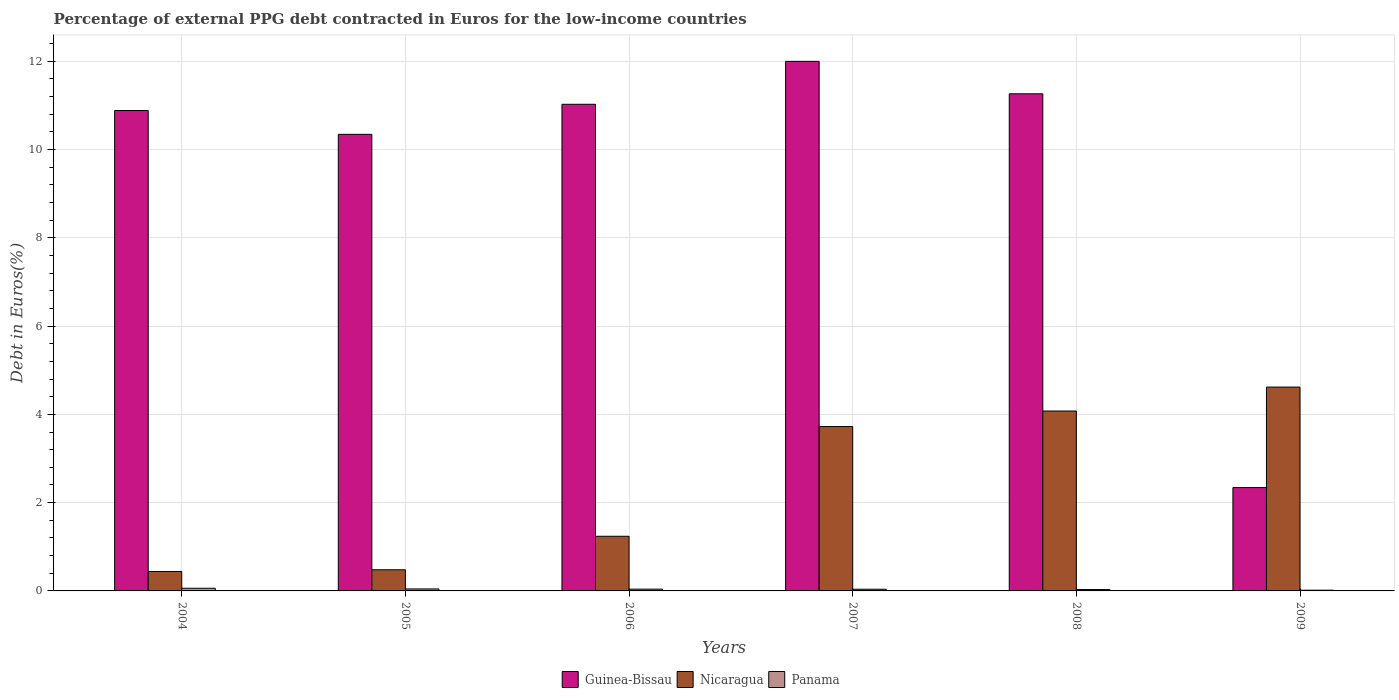How many different coloured bars are there?
Provide a succinct answer. 3. Are the number of bars on each tick of the X-axis equal?
Provide a succinct answer. Yes. In how many cases, is the number of bars for a given year not equal to the number of legend labels?
Offer a very short reply. 0. What is the percentage of external PPG debt contracted in Euros in Panama in 2005?
Ensure brevity in your answer.  0.04. Across all years, what is the maximum percentage of external PPG debt contracted in Euros in Panama?
Your response must be concise. 0.06. Across all years, what is the minimum percentage of external PPG debt contracted in Euros in Guinea-Bissau?
Ensure brevity in your answer.  2.34. In which year was the percentage of external PPG debt contracted in Euros in Panama minimum?
Provide a short and direct response. 2009. What is the total percentage of external PPG debt contracted in Euros in Nicaragua in the graph?
Offer a terse response. 14.58. What is the difference between the percentage of external PPG debt contracted in Euros in Nicaragua in 2007 and that in 2008?
Your response must be concise. -0.35. What is the difference between the percentage of external PPG debt contracted in Euros in Panama in 2007 and the percentage of external PPG debt contracted in Euros in Guinea-Bissau in 2006?
Keep it short and to the point. -10.99. What is the average percentage of external PPG debt contracted in Euros in Panama per year?
Your answer should be compact. 0.04. In the year 2008, what is the difference between the percentage of external PPG debt contracted in Euros in Nicaragua and percentage of external PPG debt contracted in Euros in Guinea-Bissau?
Offer a terse response. -7.19. In how many years, is the percentage of external PPG debt contracted in Euros in Guinea-Bissau greater than 5.6 %?
Your answer should be compact. 5. What is the ratio of the percentage of external PPG debt contracted in Euros in Nicaragua in 2004 to that in 2005?
Provide a succinct answer. 0.92. Is the percentage of external PPG debt contracted in Euros in Nicaragua in 2005 less than that in 2006?
Ensure brevity in your answer.  Yes. Is the difference between the percentage of external PPG debt contracted in Euros in Nicaragua in 2007 and 2008 greater than the difference between the percentage of external PPG debt contracted in Euros in Guinea-Bissau in 2007 and 2008?
Your answer should be very brief. No. What is the difference between the highest and the second highest percentage of external PPG debt contracted in Euros in Nicaragua?
Your answer should be very brief. 0.54. What is the difference between the highest and the lowest percentage of external PPG debt contracted in Euros in Guinea-Bissau?
Your response must be concise. 9.66. In how many years, is the percentage of external PPG debt contracted in Euros in Panama greater than the average percentage of external PPG debt contracted in Euros in Panama taken over all years?
Make the answer very short. 3. What does the 2nd bar from the left in 2007 represents?
Provide a short and direct response. Nicaragua. What does the 2nd bar from the right in 2009 represents?
Your answer should be compact. Nicaragua. Is it the case that in every year, the sum of the percentage of external PPG debt contracted in Euros in Panama and percentage of external PPG debt contracted in Euros in Guinea-Bissau is greater than the percentage of external PPG debt contracted in Euros in Nicaragua?
Your answer should be compact. No. What is the difference between two consecutive major ticks on the Y-axis?
Offer a very short reply. 2. Does the graph contain any zero values?
Keep it short and to the point. No. Where does the legend appear in the graph?
Keep it short and to the point. Bottom center. How many legend labels are there?
Provide a succinct answer. 3. What is the title of the graph?
Your response must be concise. Percentage of external PPG debt contracted in Euros for the low-income countries. What is the label or title of the X-axis?
Make the answer very short. Years. What is the label or title of the Y-axis?
Give a very brief answer. Debt in Euros(%). What is the Debt in Euros(%) of Guinea-Bissau in 2004?
Keep it short and to the point. 10.88. What is the Debt in Euros(%) in Nicaragua in 2004?
Your answer should be compact. 0.44. What is the Debt in Euros(%) of Panama in 2004?
Provide a succinct answer. 0.06. What is the Debt in Euros(%) in Guinea-Bissau in 2005?
Provide a succinct answer. 10.34. What is the Debt in Euros(%) of Nicaragua in 2005?
Ensure brevity in your answer.  0.48. What is the Debt in Euros(%) of Panama in 2005?
Your answer should be compact. 0.04. What is the Debt in Euros(%) of Guinea-Bissau in 2006?
Give a very brief answer. 11.02. What is the Debt in Euros(%) of Nicaragua in 2006?
Offer a very short reply. 1.24. What is the Debt in Euros(%) of Panama in 2006?
Make the answer very short. 0.04. What is the Debt in Euros(%) in Guinea-Bissau in 2007?
Offer a very short reply. 12. What is the Debt in Euros(%) in Nicaragua in 2007?
Make the answer very short. 3.72. What is the Debt in Euros(%) in Panama in 2007?
Make the answer very short. 0.04. What is the Debt in Euros(%) of Guinea-Bissau in 2008?
Your response must be concise. 11.26. What is the Debt in Euros(%) in Nicaragua in 2008?
Keep it short and to the point. 4.08. What is the Debt in Euros(%) of Panama in 2008?
Provide a succinct answer. 0.03. What is the Debt in Euros(%) in Guinea-Bissau in 2009?
Offer a terse response. 2.34. What is the Debt in Euros(%) of Nicaragua in 2009?
Give a very brief answer. 4.62. What is the Debt in Euros(%) of Panama in 2009?
Provide a succinct answer. 0.02. Across all years, what is the maximum Debt in Euros(%) in Guinea-Bissau?
Provide a succinct answer. 12. Across all years, what is the maximum Debt in Euros(%) in Nicaragua?
Provide a succinct answer. 4.62. Across all years, what is the maximum Debt in Euros(%) of Panama?
Your response must be concise. 0.06. Across all years, what is the minimum Debt in Euros(%) in Guinea-Bissau?
Keep it short and to the point. 2.34. Across all years, what is the minimum Debt in Euros(%) in Nicaragua?
Ensure brevity in your answer.  0.44. Across all years, what is the minimum Debt in Euros(%) of Panama?
Provide a succinct answer. 0.02. What is the total Debt in Euros(%) in Guinea-Bissau in the graph?
Provide a short and direct response. 57.85. What is the total Debt in Euros(%) in Nicaragua in the graph?
Offer a terse response. 14.58. What is the total Debt in Euros(%) in Panama in the graph?
Provide a short and direct response. 0.23. What is the difference between the Debt in Euros(%) in Guinea-Bissau in 2004 and that in 2005?
Ensure brevity in your answer.  0.54. What is the difference between the Debt in Euros(%) of Nicaragua in 2004 and that in 2005?
Your response must be concise. -0.04. What is the difference between the Debt in Euros(%) of Panama in 2004 and that in 2005?
Ensure brevity in your answer.  0.02. What is the difference between the Debt in Euros(%) of Guinea-Bissau in 2004 and that in 2006?
Offer a very short reply. -0.14. What is the difference between the Debt in Euros(%) in Nicaragua in 2004 and that in 2006?
Your answer should be compact. -0.8. What is the difference between the Debt in Euros(%) of Panama in 2004 and that in 2006?
Your answer should be compact. 0.02. What is the difference between the Debt in Euros(%) in Guinea-Bissau in 2004 and that in 2007?
Your response must be concise. -1.11. What is the difference between the Debt in Euros(%) of Nicaragua in 2004 and that in 2007?
Offer a terse response. -3.28. What is the difference between the Debt in Euros(%) of Panama in 2004 and that in 2007?
Provide a short and direct response. 0.02. What is the difference between the Debt in Euros(%) in Guinea-Bissau in 2004 and that in 2008?
Offer a very short reply. -0.38. What is the difference between the Debt in Euros(%) in Nicaragua in 2004 and that in 2008?
Provide a succinct answer. -3.64. What is the difference between the Debt in Euros(%) in Panama in 2004 and that in 2008?
Ensure brevity in your answer.  0.03. What is the difference between the Debt in Euros(%) of Guinea-Bissau in 2004 and that in 2009?
Keep it short and to the point. 8.54. What is the difference between the Debt in Euros(%) in Nicaragua in 2004 and that in 2009?
Your response must be concise. -4.18. What is the difference between the Debt in Euros(%) in Panama in 2004 and that in 2009?
Keep it short and to the point. 0.04. What is the difference between the Debt in Euros(%) in Guinea-Bissau in 2005 and that in 2006?
Ensure brevity in your answer.  -0.68. What is the difference between the Debt in Euros(%) in Nicaragua in 2005 and that in 2006?
Your answer should be compact. -0.76. What is the difference between the Debt in Euros(%) in Panama in 2005 and that in 2006?
Ensure brevity in your answer.  0. What is the difference between the Debt in Euros(%) of Guinea-Bissau in 2005 and that in 2007?
Provide a succinct answer. -1.65. What is the difference between the Debt in Euros(%) in Nicaragua in 2005 and that in 2007?
Your answer should be compact. -3.24. What is the difference between the Debt in Euros(%) of Panama in 2005 and that in 2007?
Give a very brief answer. 0.01. What is the difference between the Debt in Euros(%) in Guinea-Bissau in 2005 and that in 2008?
Provide a short and direct response. -0.92. What is the difference between the Debt in Euros(%) of Nicaragua in 2005 and that in 2008?
Make the answer very short. -3.6. What is the difference between the Debt in Euros(%) of Panama in 2005 and that in 2008?
Keep it short and to the point. 0.01. What is the difference between the Debt in Euros(%) in Guinea-Bissau in 2005 and that in 2009?
Ensure brevity in your answer.  8. What is the difference between the Debt in Euros(%) of Nicaragua in 2005 and that in 2009?
Offer a terse response. -4.14. What is the difference between the Debt in Euros(%) of Panama in 2005 and that in 2009?
Keep it short and to the point. 0.03. What is the difference between the Debt in Euros(%) of Guinea-Bissau in 2006 and that in 2007?
Your answer should be very brief. -0.97. What is the difference between the Debt in Euros(%) of Nicaragua in 2006 and that in 2007?
Offer a very short reply. -2.49. What is the difference between the Debt in Euros(%) in Panama in 2006 and that in 2007?
Provide a succinct answer. 0. What is the difference between the Debt in Euros(%) of Guinea-Bissau in 2006 and that in 2008?
Ensure brevity in your answer.  -0.24. What is the difference between the Debt in Euros(%) of Nicaragua in 2006 and that in 2008?
Provide a succinct answer. -2.84. What is the difference between the Debt in Euros(%) of Panama in 2006 and that in 2008?
Offer a very short reply. 0.01. What is the difference between the Debt in Euros(%) in Guinea-Bissau in 2006 and that in 2009?
Keep it short and to the point. 8.68. What is the difference between the Debt in Euros(%) of Nicaragua in 2006 and that in 2009?
Offer a terse response. -3.38. What is the difference between the Debt in Euros(%) of Panama in 2006 and that in 2009?
Ensure brevity in your answer.  0.02. What is the difference between the Debt in Euros(%) of Guinea-Bissau in 2007 and that in 2008?
Give a very brief answer. 0.73. What is the difference between the Debt in Euros(%) in Nicaragua in 2007 and that in 2008?
Offer a very short reply. -0.35. What is the difference between the Debt in Euros(%) of Panama in 2007 and that in 2008?
Ensure brevity in your answer.  0.01. What is the difference between the Debt in Euros(%) of Guinea-Bissau in 2007 and that in 2009?
Ensure brevity in your answer.  9.66. What is the difference between the Debt in Euros(%) in Nicaragua in 2007 and that in 2009?
Provide a succinct answer. -0.89. What is the difference between the Debt in Euros(%) in Panama in 2007 and that in 2009?
Your answer should be compact. 0.02. What is the difference between the Debt in Euros(%) in Guinea-Bissau in 2008 and that in 2009?
Ensure brevity in your answer.  8.92. What is the difference between the Debt in Euros(%) in Nicaragua in 2008 and that in 2009?
Make the answer very short. -0.54. What is the difference between the Debt in Euros(%) in Panama in 2008 and that in 2009?
Offer a terse response. 0.01. What is the difference between the Debt in Euros(%) of Guinea-Bissau in 2004 and the Debt in Euros(%) of Nicaragua in 2005?
Ensure brevity in your answer.  10.4. What is the difference between the Debt in Euros(%) in Guinea-Bissau in 2004 and the Debt in Euros(%) in Panama in 2005?
Make the answer very short. 10.84. What is the difference between the Debt in Euros(%) of Nicaragua in 2004 and the Debt in Euros(%) of Panama in 2005?
Your response must be concise. 0.4. What is the difference between the Debt in Euros(%) in Guinea-Bissau in 2004 and the Debt in Euros(%) in Nicaragua in 2006?
Give a very brief answer. 9.65. What is the difference between the Debt in Euros(%) in Guinea-Bissau in 2004 and the Debt in Euros(%) in Panama in 2006?
Provide a short and direct response. 10.84. What is the difference between the Debt in Euros(%) of Nicaragua in 2004 and the Debt in Euros(%) of Panama in 2006?
Provide a short and direct response. 0.4. What is the difference between the Debt in Euros(%) in Guinea-Bissau in 2004 and the Debt in Euros(%) in Nicaragua in 2007?
Your answer should be very brief. 7.16. What is the difference between the Debt in Euros(%) in Guinea-Bissau in 2004 and the Debt in Euros(%) in Panama in 2007?
Offer a terse response. 10.85. What is the difference between the Debt in Euros(%) in Nicaragua in 2004 and the Debt in Euros(%) in Panama in 2007?
Keep it short and to the point. 0.4. What is the difference between the Debt in Euros(%) in Guinea-Bissau in 2004 and the Debt in Euros(%) in Nicaragua in 2008?
Give a very brief answer. 6.81. What is the difference between the Debt in Euros(%) of Guinea-Bissau in 2004 and the Debt in Euros(%) of Panama in 2008?
Your response must be concise. 10.85. What is the difference between the Debt in Euros(%) of Nicaragua in 2004 and the Debt in Euros(%) of Panama in 2008?
Provide a short and direct response. 0.41. What is the difference between the Debt in Euros(%) in Guinea-Bissau in 2004 and the Debt in Euros(%) in Nicaragua in 2009?
Offer a terse response. 6.27. What is the difference between the Debt in Euros(%) in Guinea-Bissau in 2004 and the Debt in Euros(%) in Panama in 2009?
Your response must be concise. 10.87. What is the difference between the Debt in Euros(%) in Nicaragua in 2004 and the Debt in Euros(%) in Panama in 2009?
Provide a short and direct response. 0.42. What is the difference between the Debt in Euros(%) in Guinea-Bissau in 2005 and the Debt in Euros(%) in Nicaragua in 2006?
Offer a terse response. 9.11. What is the difference between the Debt in Euros(%) in Guinea-Bissau in 2005 and the Debt in Euros(%) in Panama in 2006?
Your response must be concise. 10.3. What is the difference between the Debt in Euros(%) of Nicaragua in 2005 and the Debt in Euros(%) of Panama in 2006?
Offer a very short reply. 0.44. What is the difference between the Debt in Euros(%) in Guinea-Bissau in 2005 and the Debt in Euros(%) in Nicaragua in 2007?
Offer a very short reply. 6.62. What is the difference between the Debt in Euros(%) in Guinea-Bissau in 2005 and the Debt in Euros(%) in Panama in 2007?
Offer a very short reply. 10.31. What is the difference between the Debt in Euros(%) in Nicaragua in 2005 and the Debt in Euros(%) in Panama in 2007?
Ensure brevity in your answer.  0.44. What is the difference between the Debt in Euros(%) in Guinea-Bissau in 2005 and the Debt in Euros(%) in Nicaragua in 2008?
Make the answer very short. 6.27. What is the difference between the Debt in Euros(%) of Guinea-Bissau in 2005 and the Debt in Euros(%) of Panama in 2008?
Your response must be concise. 10.31. What is the difference between the Debt in Euros(%) in Nicaragua in 2005 and the Debt in Euros(%) in Panama in 2008?
Provide a short and direct response. 0.45. What is the difference between the Debt in Euros(%) of Guinea-Bissau in 2005 and the Debt in Euros(%) of Nicaragua in 2009?
Provide a succinct answer. 5.73. What is the difference between the Debt in Euros(%) of Guinea-Bissau in 2005 and the Debt in Euros(%) of Panama in 2009?
Your response must be concise. 10.33. What is the difference between the Debt in Euros(%) of Nicaragua in 2005 and the Debt in Euros(%) of Panama in 2009?
Keep it short and to the point. 0.46. What is the difference between the Debt in Euros(%) in Guinea-Bissau in 2006 and the Debt in Euros(%) in Nicaragua in 2007?
Make the answer very short. 7.3. What is the difference between the Debt in Euros(%) in Guinea-Bissau in 2006 and the Debt in Euros(%) in Panama in 2007?
Give a very brief answer. 10.99. What is the difference between the Debt in Euros(%) of Nicaragua in 2006 and the Debt in Euros(%) of Panama in 2007?
Provide a short and direct response. 1.2. What is the difference between the Debt in Euros(%) in Guinea-Bissau in 2006 and the Debt in Euros(%) in Nicaragua in 2008?
Keep it short and to the point. 6.95. What is the difference between the Debt in Euros(%) in Guinea-Bissau in 2006 and the Debt in Euros(%) in Panama in 2008?
Offer a very short reply. 10.99. What is the difference between the Debt in Euros(%) of Nicaragua in 2006 and the Debt in Euros(%) of Panama in 2008?
Your answer should be compact. 1.21. What is the difference between the Debt in Euros(%) in Guinea-Bissau in 2006 and the Debt in Euros(%) in Nicaragua in 2009?
Ensure brevity in your answer.  6.41. What is the difference between the Debt in Euros(%) in Guinea-Bissau in 2006 and the Debt in Euros(%) in Panama in 2009?
Give a very brief answer. 11.01. What is the difference between the Debt in Euros(%) of Nicaragua in 2006 and the Debt in Euros(%) of Panama in 2009?
Offer a very short reply. 1.22. What is the difference between the Debt in Euros(%) of Guinea-Bissau in 2007 and the Debt in Euros(%) of Nicaragua in 2008?
Keep it short and to the point. 7.92. What is the difference between the Debt in Euros(%) in Guinea-Bissau in 2007 and the Debt in Euros(%) in Panama in 2008?
Give a very brief answer. 11.97. What is the difference between the Debt in Euros(%) of Nicaragua in 2007 and the Debt in Euros(%) of Panama in 2008?
Provide a short and direct response. 3.69. What is the difference between the Debt in Euros(%) of Guinea-Bissau in 2007 and the Debt in Euros(%) of Nicaragua in 2009?
Offer a very short reply. 7.38. What is the difference between the Debt in Euros(%) of Guinea-Bissau in 2007 and the Debt in Euros(%) of Panama in 2009?
Ensure brevity in your answer.  11.98. What is the difference between the Debt in Euros(%) of Nicaragua in 2007 and the Debt in Euros(%) of Panama in 2009?
Keep it short and to the point. 3.71. What is the difference between the Debt in Euros(%) in Guinea-Bissau in 2008 and the Debt in Euros(%) in Nicaragua in 2009?
Provide a succinct answer. 6.64. What is the difference between the Debt in Euros(%) in Guinea-Bissau in 2008 and the Debt in Euros(%) in Panama in 2009?
Offer a terse response. 11.25. What is the difference between the Debt in Euros(%) in Nicaragua in 2008 and the Debt in Euros(%) in Panama in 2009?
Your answer should be compact. 4.06. What is the average Debt in Euros(%) in Guinea-Bissau per year?
Make the answer very short. 9.64. What is the average Debt in Euros(%) of Nicaragua per year?
Your answer should be compact. 2.43. What is the average Debt in Euros(%) in Panama per year?
Make the answer very short. 0.04. In the year 2004, what is the difference between the Debt in Euros(%) of Guinea-Bissau and Debt in Euros(%) of Nicaragua?
Provide a succinct answer. 10.44. In the year 2004, what is the difference between the Debt in Euros(%) in Guinea-Bissau and Debt in Euros(%) in Panama?
Your answer should be very brief. 10.82. In the year 2004, what is the difference between the Debt in Euros(%) of Nicaragua and Debt in Euros(%) of Panama?
Your response must be concise. 0.38. In the year 2005, what is the difference between the Debt in Euros(%) in Guinea-Bissau and Debt in Euros(%) in Nicaragua?
Ensure brevity in your answer.  9.86. In the year 2005, what is the difference between the Debt in Euros(%) in Guinea-Bissau and Debt in Euros(%) in Panama?
Give a very brief answer. 10.3. In the year 2005, what is the difference between the Debt in Euros(%) in Nicaragua and Debt in Euros(%) in Panama?
Provide a succinct answer. 0.43. In the year 2006, what is the difference between the Debt in Euros(%) of Guinea-Bissau and Debt in Euros(%) of Nicaragua?
Offer a terse response. 9.79. In the year 2006, what is the difference between the Debt in Euros(%) of Guinea-Bissau and Debt in Euros(%) of Panama?
Your answer should be very brief. 10.98. In the year 2006, what is the difference between the Debt in Euros(%) in Nicaragua and Debt in Euros(%) in Panama?
Your answer should be compact. 1.2. In the year 2007, what is the difference between the Debt in Euros(%) in Guinea-Bissau and Debt in Euros(%) in Nicaragua?
Your answer should be very brief. 8.27. In the year 2007, what is the difference between the Debt in Euros(%) in Guinea-Bissau and Debt in Euros(%) in Panama?
Provide a short and direct response. 11.96. In the year 2007, what is the difference between the Debt in Euros(%) of Nicaragua and Debt in Euros(%) of Panama?
Your answer should be very brief. 3.69. In the year 2008, what is the difference between the Debt in Euros(%) of Guinea-Bissau and Debt in Euros(%) of Nicaragua?
Provide a short and direct response. 7.19. In the year 2008, what is the difference between the Debt in Euros(%) in Guinea-Bissau and Debt in Euros(%) in Panama?
Provide a succinct answer. 11.23. In the year 2008, what is the difference between the Debt in Euros(%) in Nicaragua and Debt in Euros(%) in Panama?
Provide a succinct answer. 4.05. In the year 2009, what is the difference between the Debt in Euros(%) in Guinea-Bissau and Debt in Euros(%) in Nicaragua?
Your answer should be very brief. -2.28. In the year 2009, what is the difference between the Debt in Euros(%) of Guinea-Bissau and Debt in Euros(%) of Panama?
Your answer should be very brief. 2.33. In the year 2009, what is the difference between the Debt in Euros(%) of Nicaragua and Debt in Euros(%) of Panama?
Make the answer very short. 4.6. What is the ratio of the Debt in Euros(%) in Guinea-Bissau in 2004 to that in 2005?
Your answer should be compact. 1.05. What is the ratio of the Debt in Euros(%) in Nicaragua in 2004 to that in 2005?
Give a very brief answer. 0.92. What is the ratio of the Debt in Euros(%) of Panama in 2004 to that in 2005?
Keep it short and to the point. 1.34. What is the ratio of the Debt in Euros(%) of Guinea-Bissau in 2004 to that in 2006?
Offer a very short reply. 0.99. What is the ratio of the Debt in Euros(%) in Nicaragua in 2004 to that in 2006?
Give a very brief answer. 0.36. What is the ratio of the Debt in Euros(%) of Panama in 2004 to that in 2006?
Your answer should be very brief. 1.5. What is the ratio of the Debt in Euros(%) of Guinea-Bissau in 2004 to that in 2007?
Make the answer very short. 0.91. What is the ratio of the Debt in Euros(%) in Nicaragua in 2004 to that in 2007?
Provide a short and direct response. 0.12. What is the ratio of the Debt in Euros(%) of Panama in 2004 to that in 2007?
Provide a short and direct response. 1.57. What is the ratio of the Debt in Euros(%) of Guinea-Bissau in 2004 to that in 2008?
Your answer should be compact. 0.97. What is the ratio of the Debt in Euros(%) in Nicaragua in 2004 to that in 2008?
Give a very brief answer. 0.11. What is the ratio of the Debt in Euros(%) of Panama in 2004 to that in 2008?
Offer a terse response. 1.96. What is the ratio of the Debt in Euros(%) of Guinea-Bissau in 2004 to that in 2009?
Your answer should be very brief. 4.65. What is the ratio of the Debt in Euros(%) in Nicaragua in 2004 to that in 2009?
Keep it short and to the point. 0.1. What is the ratio of the Debt in Euros(%) of Panama in 2004 to that in 2009?
Give a very brief answer. 3.7. What is the ratio of the Debt in Euros(%) in Guinea-Bissau in 2005 to that in 2006?
Your answer should be compact. 0.94. What is the ratio of the Debt in Euros(%) in Nicaragua in 2005 to that in 2006?
Make the answer very short. 0.39. What is the ratio of the Debt in Euros(%) of Panama in 2005 to that in 2006?
Your answer should be compact. 1.12. What is the ratio of the Debt in Euros(%) in Guinea-Bissau in 2005 to that in 2007?
Provide a succinct answer. 0.86. What is the ratio of the Debt in Euros(%) of Nicaragua in 2005 to that in 2007?
Provide a short and direct response. 0.13. What is the ratio of the Debt in Euros(%) of Panama in 2005 to that in 2007?
Provide a succinct answer. 1.17. What is the ratio of the Debt in Euros(%) of Guinea-Bissau in 2005 to that in 2008?
Your response must be concise. 0.92. What is the ratio of the Debt in Euros(%) of Nicaragua in 2005 to that in 2008?
Offer a very short reply. 0.12. What is the ratio of the Debt in Euros(%) of Panama in 2005 to that in 2008?
Your answer should be compact. 1.46. What is the ratio of the Debt in Euros(%) of Guinea-Bissau in 2005 to that in 2009?
Ensure brevity in your answer.  4.42. What is the ratio of the Debt in Euros(%) of Nicaragua in 2005 to that in 2009?
Offer a very short reply. 0.1. What is the ratio of the Debt in Euros(%) of Panama in 2005 to that in 2009?
Offer a very short reply. 2.75. What is the ratio of the Debt in Euros(%) in Guinea-Bissau in 2006 to that in 2007?
Provide a succinct answer. 0.92. What is the ratio of the Debt in Euros(%) of Nicaragua in 2006 to that in 2007?
Ensure brevity in your answer.  0.33. What is the ratio of the Debt in Euros(%) of Panama in 2006 to that in 2007?
Make the answer very short. 1.05. What is the ratio of the Debt in Euros(%) in Guinea-Bissau in 2006 to that in 2008?
Ensure brevity in your answer.  0.98. What is the ratio of the Debt in Euros(%) in Nicaragua in 2006 to that in 2008?
Provide a short and direct response. 0.3. What is the ratio of the Debt in Euros(%) of Panama in 2006 to that in 2008?
Ensure brevity in your answer.  1.31. What is the ratio of the Debt in Euros(%) of Guinea-Bissau in 2006 to that in 2009?
Offer a very short reply. 4.71. What is the ratio of the Debt in Euros(%) of Nicaragua in 2006 to that in 2009?
Keep it short and to the point. 0.27. What is the ratio of the Debt in Euros(%) in Panama in 2006 to that in 2009?
Your answer should be very brief. 2.47. What is the ratio of the Debt in Euros(%) in Guinea-Bissau in 2007 to that in 2008?
Your response must be concise. 1.07. What is the ratio of the Debt in Euros(%) in Nicaragua in 2007 to that in 2008?
Provide a succinct answer. 0.91. What is the ratio of the Debt in Euros(%) in Panama in 2007 to that in 2008?
Provide a short and direct response. 1.24. What is the ratio of the Debt in Euros(%) in Guinea-Bissau in 2007 to that in 2009?
Offer a very short reply. 5.12. What is the ratio of the Debt in Euros(%) in Nicaragua in 2007 to that in 2009?
Your response must be concise. 0.81. What is the ratio of the Debt in Euros(%) in Panama in 2007 to that in 2009?
Your answer should be very brief. 2.35. What is the ratio of the Debt in Euros(%) of Guinea-Bissau in 2008 to that in 2009?
Make the answer very short. 4.81. What is the ratio of the Debt in Euros(%) of Nicaragua in 2008 to that in 2009?
Offer a terse response. 0.88. What is the ratio of the Debt in Euros(%) in Panama in 2008 to that in 2009?
Your answer should be compact. 1.89. What is the difference between the highest and the second highest Debt in Euros(%) in Guinea-Bissau?
Provide a short and direct response. 0.73. What is the difference between the highest and the second highest Debt in Euros(%) of Nicaragua?
Provide a succinct answer. 0.54. What is the difference between the highest and the second highest Debt in Euros(%) of Panama?
Provide a succinct answer. 0.02. What is the difference between the highest and the lowest Debt in Euros(%) of Guinea-Bissau?
Ensure brevity in your answer.  9.66. What is the difference between the highest and the lowest Debt in Euros(%) in Nicaragua?
Ensure brevity in your answer.  4.18. What is the difference between the highest and the lowest Debt in Euros(%) in Panama?
Offer a terse response. 0.04. 